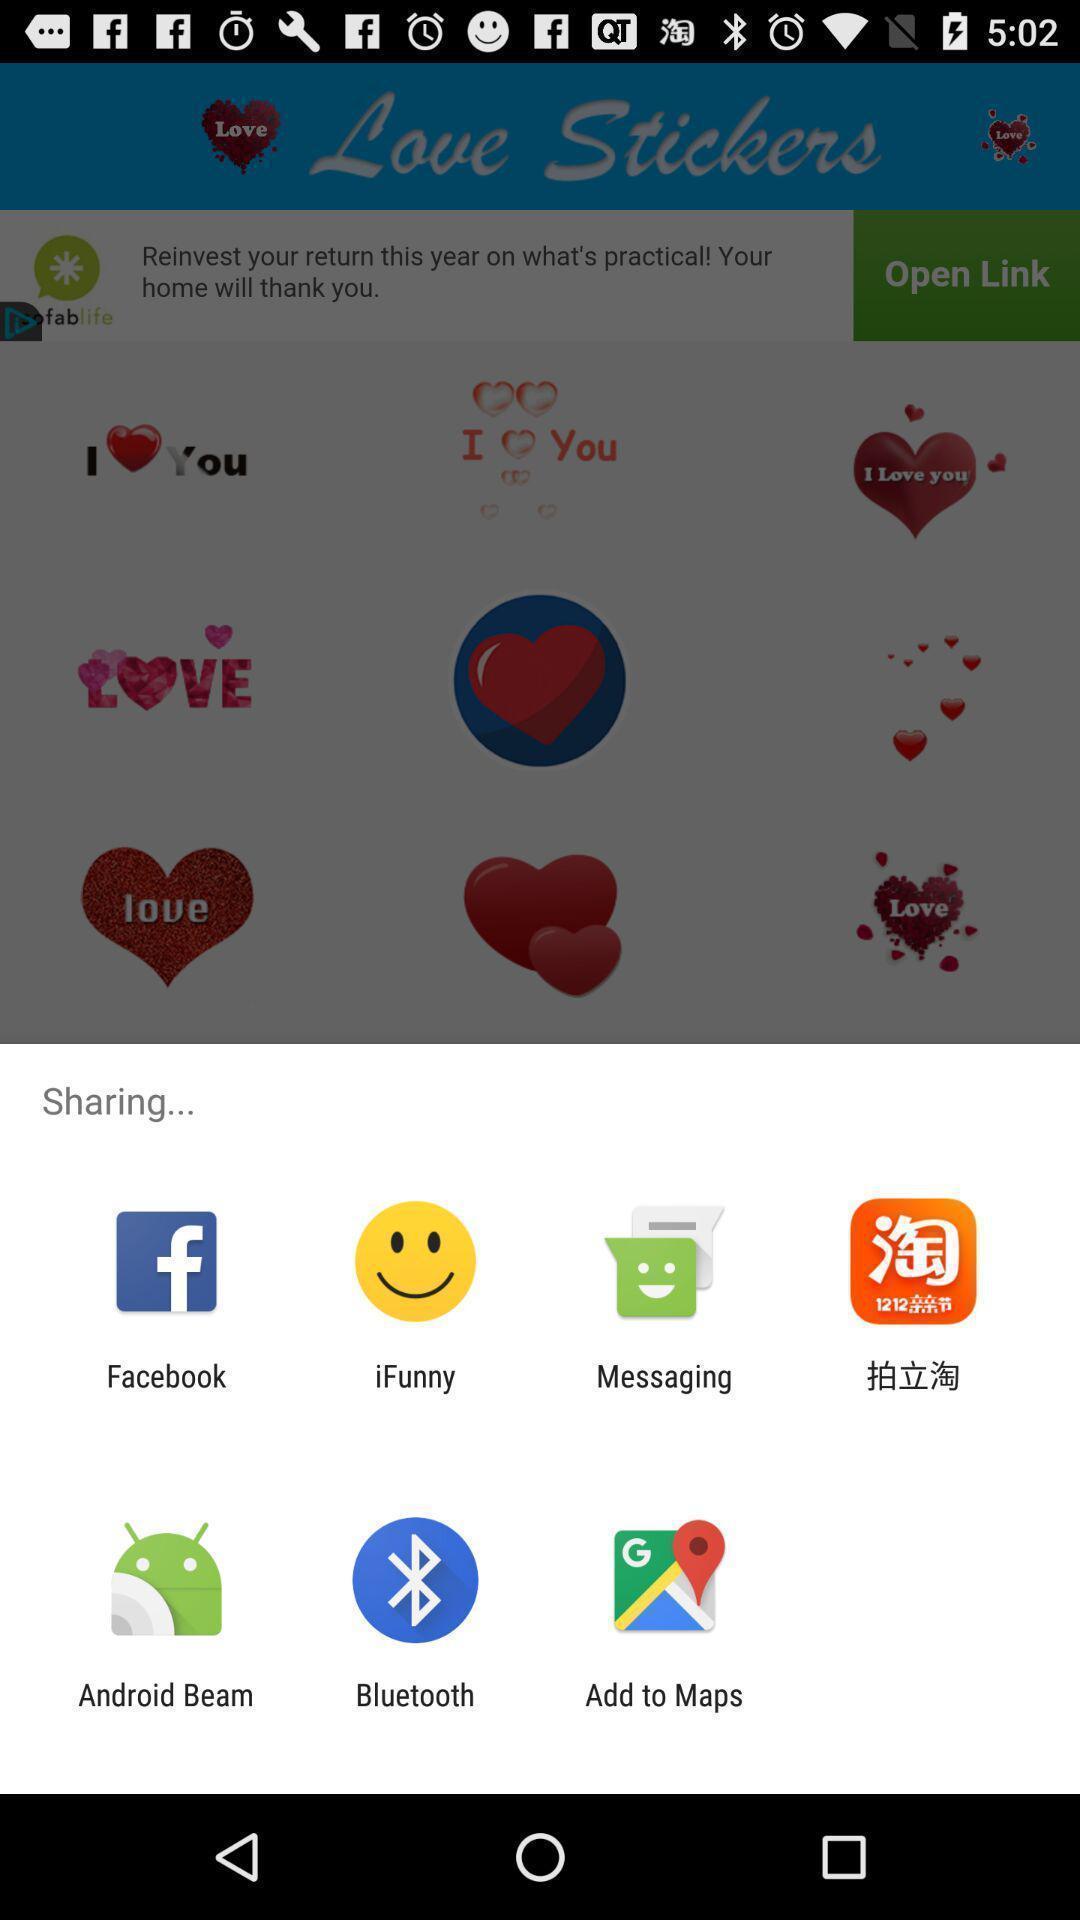What is the overall content of this screenshot? Pop-up with different options for sharing a link. 